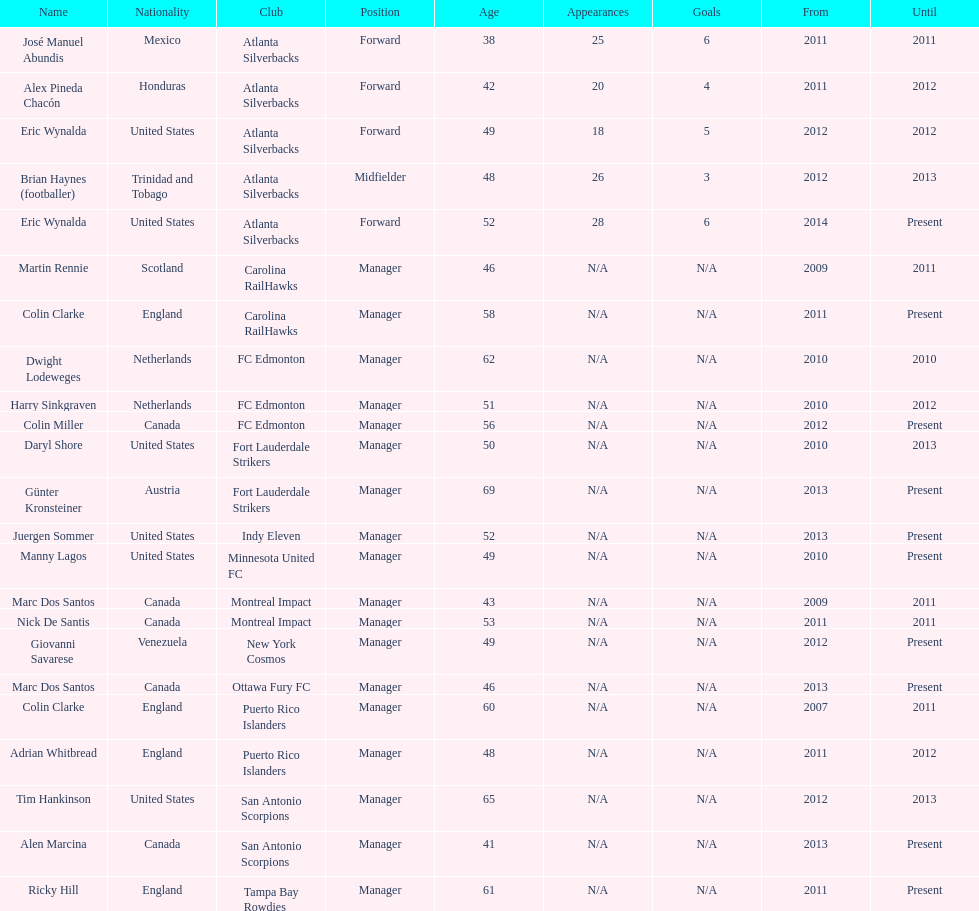What year did marc dos santos start as coach? 2009. Besides marc dos santos, what other coach started in 2009? Martin Rennie. Can you parse all the data within this table? {'header': ['Name', 'Nationality', 'Club', 'Position', 'Age', 'Appearances', 'Goals', 'From', 'Until'], 'rows': [['José Manuel Abundis', 'Mexico', 'Atlanta Silverbacks', 'Forward', '38', '25', '6', '2011', '2011'], ['Alex Pineda Chacón', 'Honduras', 'Atlanta Silverbacks', 'Forward', '42', '20', '4', '2011', '2012'], ['Eric Wynalda', 'United States', 'Atlanta Silverbacks', 'Forward', '49', '18', '5', '2012', '2012'], ['Brian Haynes (footballer)', 'Trinidad and Tobago', 'Atlanta Silverbacks', 'Midfielder', '48', '26', '3', '2012', '2013'], ['Eric Wynalda', 'United States', 'Atlanta Silverbacks', 'Forward', '52', '28', '6', '2014', 'Present'], ['Martin Rennie', 'Scotland', 'Carolina RailHawks', 'Manager', '46', 'N/A', 'N/A', '2009', '2011'], ['Colin Clarke', 'England', 'Carolina RailHawks', 'Manager', '58', 'N/A', 'N/A', '2011', 'Present'], ['Dwight Lodeweges', 'Netherlands', 'FC Edmonton', 'Manager', '62', 'N/A', 'N/A', '2010', '2010'], ['Harry Sinkgraven', 'Netherlands', 'FC Edmonton', 'Manager', '51', 'N/A', 'N/A', '2010', '2012'], ['Colin Miller', 'Canada', 'FC Edmonton', 'Manager', '56', 'N/A', 'N/A', '2012', 'Present'], ['Daryl Shore', 'United States', 'Fort Lauderdale Strikers', 'Manager', '50', 'N/A', 'N/A', '2010', '2013'], ['Günter Kronsteiner', 'Austria', 'Fort Lauderdale Strikers', 'Manager', '69', 'N/A', 'N/A', '2013', 'Present'], ['Juergen Sommer', 'United States', 'Indy Eleven', 'Manager', '52', 'N/A', 'N/A', '2013', 'Present'], ['Manny Lagos', 'United States', 'Minnesota United FC', 'Manager', '49', 'N/A', 'N/A', '2010', 'Present'], ['Marc Dos Santos', 'Canada', 'Montreal Impact', 'Manager', '43', 'N/A', 'N/A', '2009', '2011'], ['Nick De Santis', 'Canada', 'Montreal Impact', 'Manager', '53', 'N/A', 'N/A', '2011', '2011'], ['Giovanni Savarese', 'Venezuela', 'New York Cosmos', 'Manager', '49', 'N/A', 'N/A', '2012', 'Present'], ['Marc Dos Santos', 'Canada', 'Ottawa Fury FC', 'Manager', '46', 'N/A', 'N/A', '2013', 'Present'], ['Colin Clarke', 'England', 'Puerto Rico Islanders', 'Manager', '60', 'N/A', 'N/A', '2007', '2011'], ['Adrian Whitbread', 'England', 'Puerto Rico Islanders', 'Manager', '48', 'N/A', 'N/A', '2011', '2012'], ['Tim Hankinson', 'United States', 'San Antonio Scorpions', 'Manager', '65', 'N/A', 'N/A', '2012', '2013'], ['Alen Marcina', 'Canada', 'San Antonio Scorpions', 'Manager', '41', 'N/A', 'N/A', '2013', 'Present'], ['Ricky Hill', 'England', 'Tampa Bay Rowdies', 'Manager', '61', 'N/A', 'N/A', '2011', 'Present']]} 